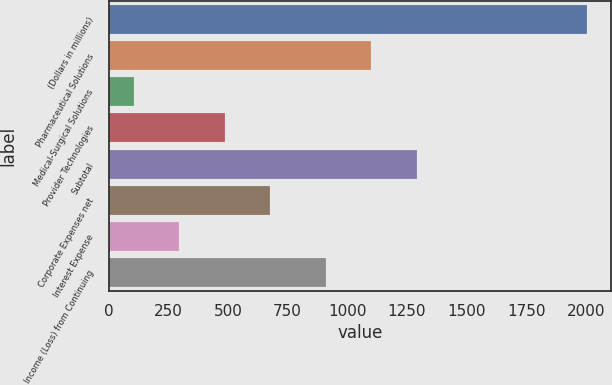Convert chart to OTSL. <chart><loc_0><loc_0><loc_500><loc_500><bar_chart><fcel>(Dollars in millions)<fcel>Pharmaceutical Solutions<fcel>Medical-Surgical Solutions<fcel>Provider Technologies<fcel>Subtotal<fcel>Corporate Expenses net<fcel>Interest Expense<fcel>Income (Loss) from Continuing<nl><fcel>2004<fcel>1101.16<fcel>106.4<fcel>485.92<fcel>1290.92<fcel>675.68<fcel>296.16<fcel>911.4<nl></chart> 